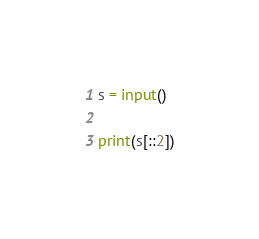Convert code to text. <code><loc_0><loc_0><loc_500><loc_500><_Python_>s = input()

print(s[::2])
</code> 